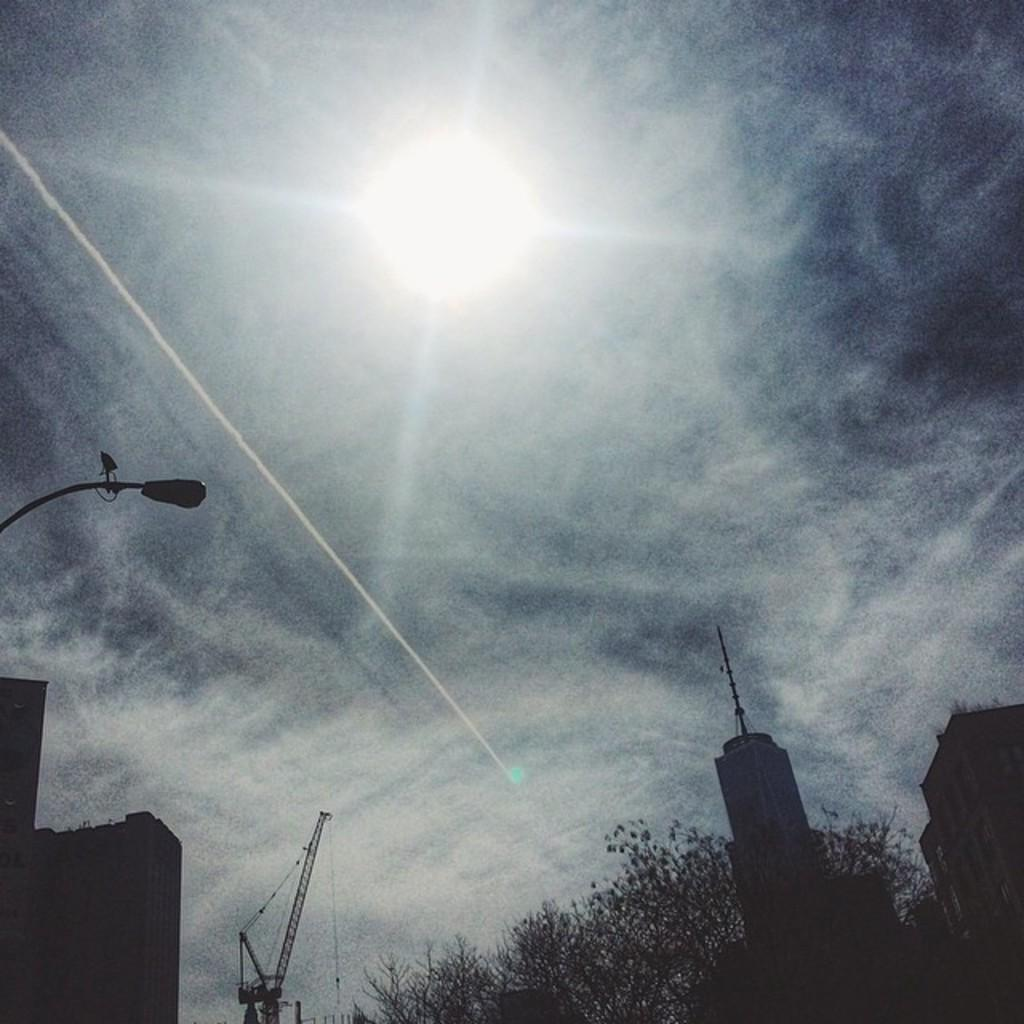What type of structures can be seen in the image? There are buildings in the image. Can you describe the condition of the plant in the image? There is a dry plant in the front bottom side of the image. What is located on the left side of the image? There is a light pole and a building on the left side of the image. What is visible at the top of the image? The sky is visible at the top of the image, and the sun is observable in the sky. Can you describe the stream flowing through the yard in the image? There is no stream or yard present in the image; it features buildings, a dry plant, a light pole, and a building on the left side of the image. 